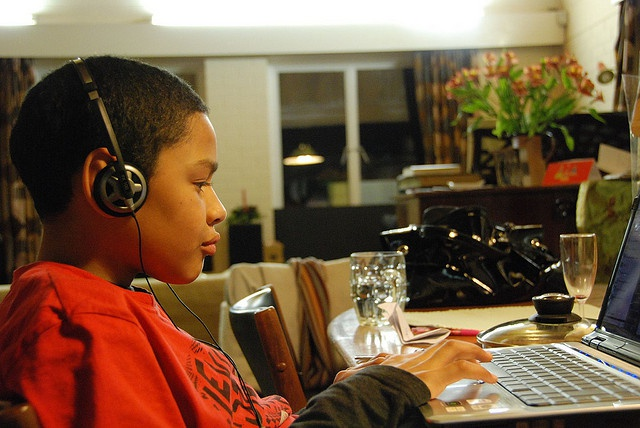Describe the objects in this image and their specific colors. I can see people in white, black, maroon, red, and brown tones, laptop in white, darkgray, black, tan, and gray tones, handbag in white, black, olive, and gray tones, couch in white, olive, and maroon tones, and potted plant in white, olive, black, and maroon tones in this image. 